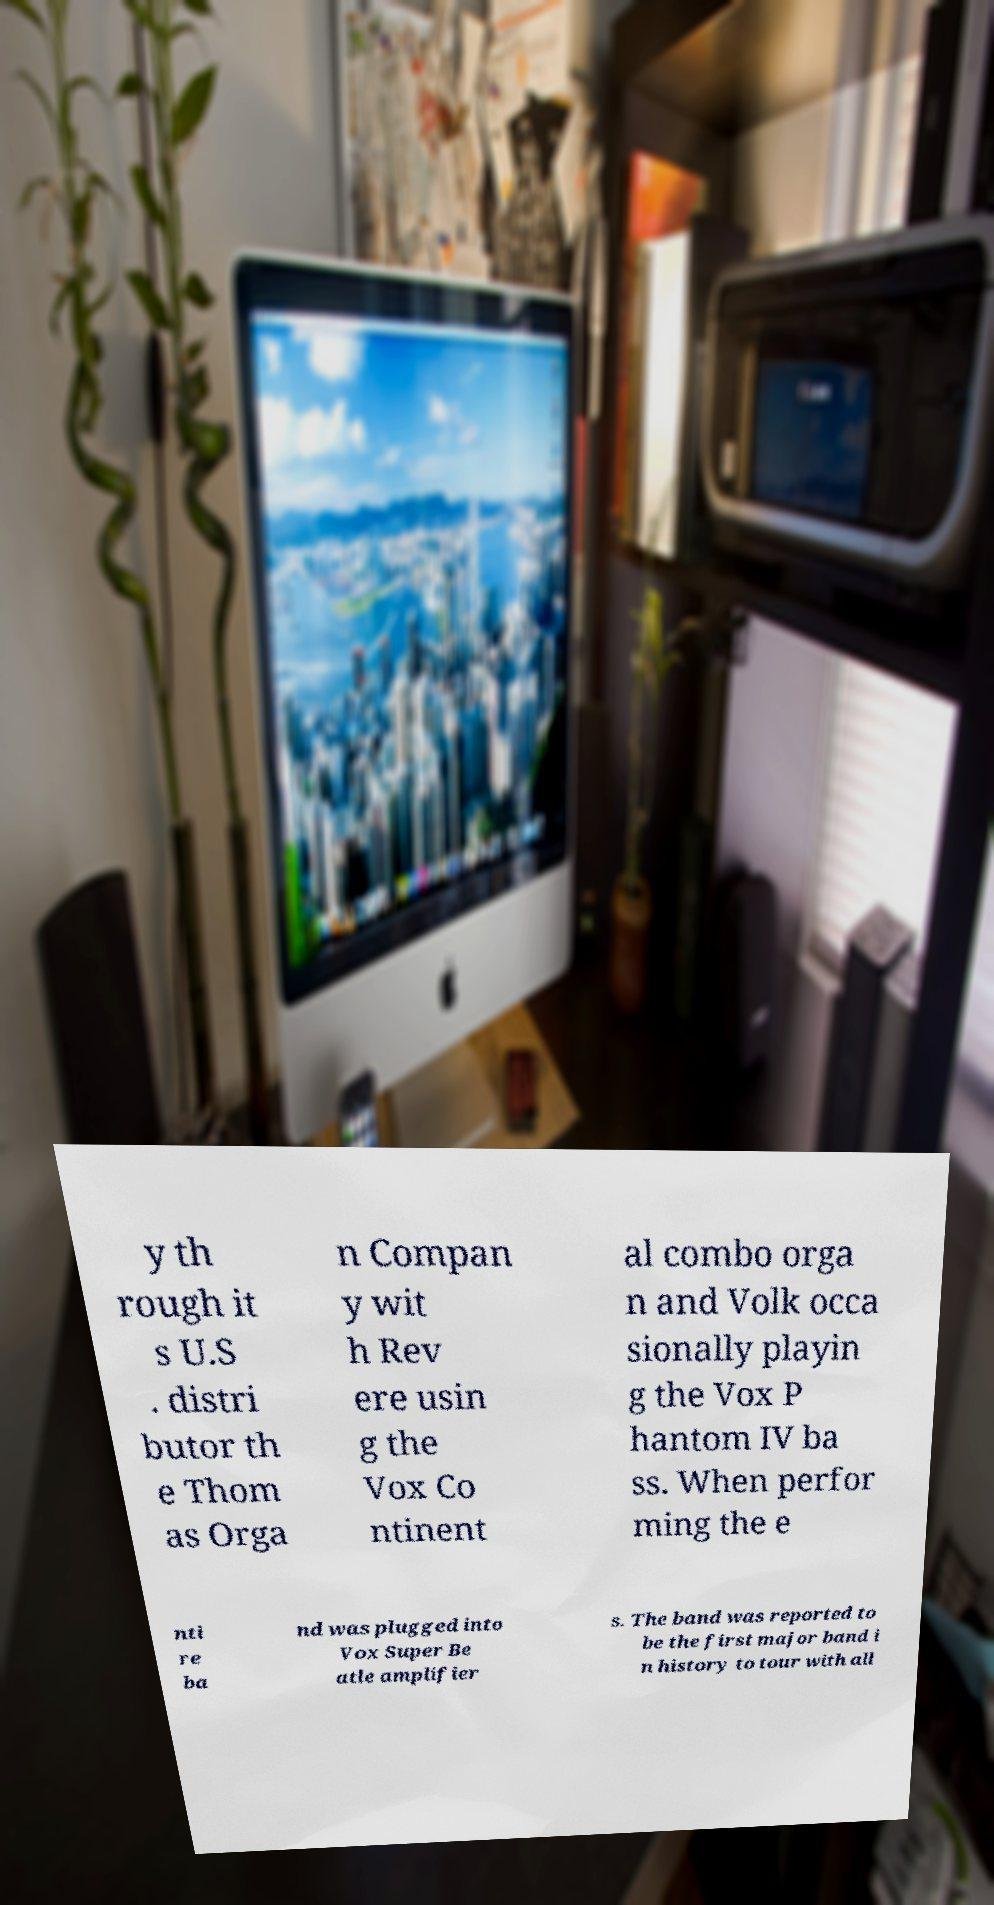Please read and relay the text visible in this image. What does it say? y th rough it s U.S . distri butor th e Thom as Orga n Compan y wit h Rev ere usin g the Vox Co ntinent al combo orga n and Volk occa sionally playin g the Vox P hantom IV ba ss. When perfor ming the e nti re ba nd was plugged into Vox Super Be atle amplifier s. The band was reported to be the first major band i n history to tour with all 